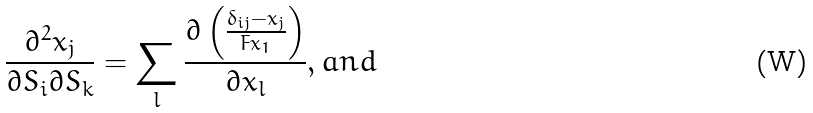Convert formula to latex. <formula><loc_0><loc_0><loc_500><loc_500>\frac { \partial ^ { 2 } x _ { j } } { \partial S _ { i } \partial S _ { k } } = \sum _ { l } \frac { \partial \left ( \frac { \delta _ { i j } - x _ { j } } { F x _ { 1 } } \right ) } { \partial x _ { l } } , a n d</formula> 